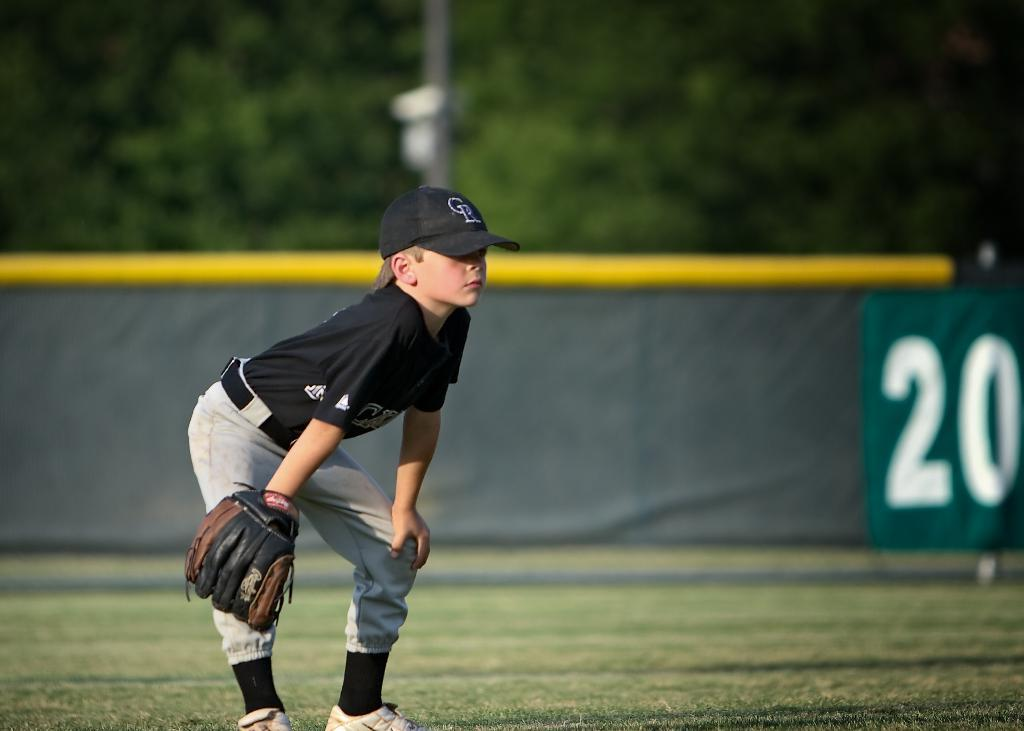<image>
Create a compact narrative representing the image presented. the number 20 that is on a wall 